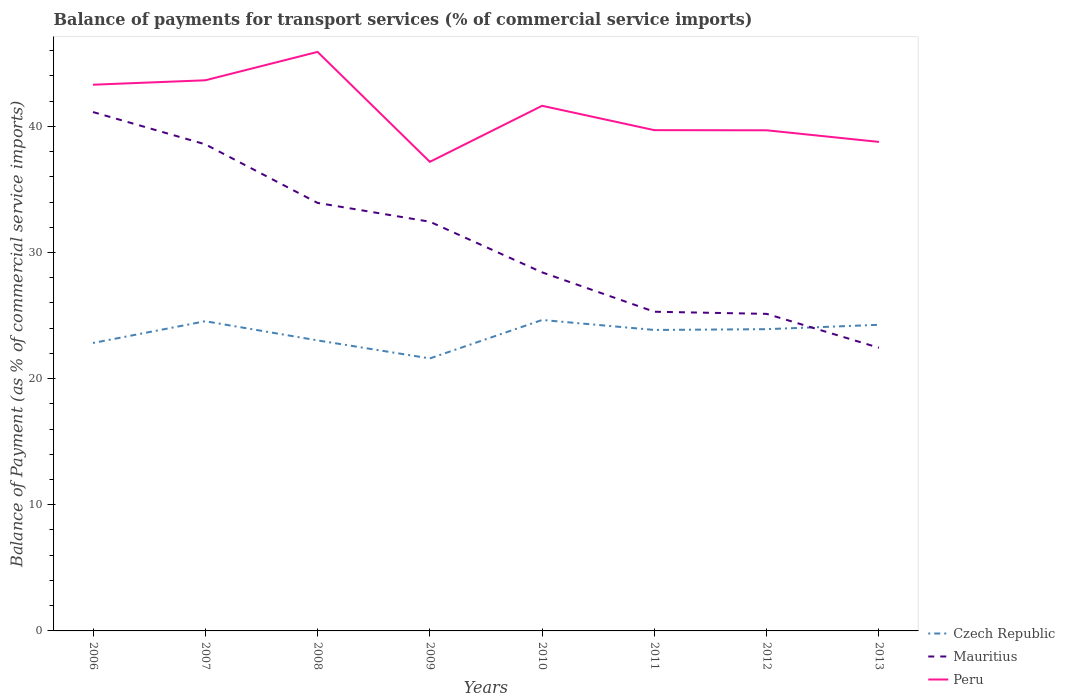Across all years, what is the maximum balance of payments for transport services in Czech Republic?
Give a very brief answer. 21.6. In which year was the balance of payments for transport services in Peru maximum?
Your answer should be very brief. 2009. What is the total balance of payments for transport services in Mauritius in the graph?
Provide a short and direct response. 2.86. What is the difference between the highest and the second highest balance of payments for transport services in Czech Republic?
Offer a very short reply. 3.05. What is the difference between the highest and the lowest balance of payments for transport services in Peru?
Provide a succinct answer. 4. How many lines are there?
Offer a terse response. 3. What is the difference between two consecutive major ticks on the Y-axis?
Provide a short and direct response. 10. Are the values on the major ticks of Y-axis written in scientific E-notation?
Provide a succinct answer. No. Does the graph contain any zero values?
Your response must be concise. No. Where does the legend appear in the graph?
Offer a very short reply. Bottom right. How many legend labels are there?
Your response must be concise. 3. How are the legend labels stacked?
Your answer should be very brief. Vertical. What is the title of the graph?
Ensure brevity in your answer.  Balance of payments for transport services (% of commercial service imports). Does "East Asia (developing only)" appear as one of the legend labels in the graph?
Give a very brief answer. No. What is the label or title of the X-axis?
Keep it short and to the point. Years. What is the label or title of the Y-axis?
Keep it short and to the point. Balance of Payment (as % of commercial service imports). What is the Balance of Payment (as % of commercial service imports) in Czech Republic in 2006?
Make the answer very short. 22.82. What is the Balance of Payment (as % of commercial service imports) of Mauritius in 2006?
Your answer should be very brief. 41.13. What is the Balance of Payment (as % of commercial service imports) of Peru in 2006?
Provide a succinct answer. 43.3. What is the Balance of Payment (as % of commercial service imports) of Czech Republic in 2007?
Provide a short and direct response. 24.55. What is the Balance of Payment (as % of commercial service imports) of Mauritius in 2007?
Your response must be concise. 38.57. What is the Balance of Payment (as % of commercial service imports) in Peru in 2007?
Provide a succinct answer. 43.65. What is the Balance of Payment (as % of commercial service imports) in Czech Republic in 2008?
Your response must be concise. 23.03. What is the Balance of Payment (as % of commercial service imports) in Mauritius in 2008?
Give a very brief answer. 33.93. What is the Balance of Payment (as % of commercial service imports) in Peru in 2008?
Make the answer very short. 45.9. What is the Balance of Payment (as % of commercial service imports) in Czech Republic in 2009?
Your answer should be compact. 21.6. What is the Balance of Payment (as % of commercial service imports) in Mauritius in 2009?
Provide a succinct answer. 32.44. What is the Balance of Payment (as % of commercial service imports) in Peru in 2009?
Offer a terse response. 37.18. What is the Balance of Payment (as % of commercial service imports) of Czech Republic in 2010?
Ensure brevity in your answer.  24.65. What is the Balance of Payment (as % of commercial service imports) in Mauritius in 2010?
Offer a very short reply. 28.42. What is the Balance of Payment (as % of commercial service imports) of Peru in 2010?
Your answer should be compact. 41.63. What is the Balance of Payment (as % of commercial service imports) in Czech Republic in 2011?
Your response must be concise. 23.86. What is the Balance of Payment (as % of commercial service imports) in Mauritius in 2011?
Offer a terse response. 25.3. What is the Balance of Payment (as % of commercial service imports) in Peru in 2011?
Provide a succinct answer. 39.69. What is the Balance of Payment (as % of commercial service imports) in Czech Republic in 2012?
Ensure brevity in your answer.  23.92. What is the Balance of Payment (as % of commercial service imports) of Mauritius in 2012?
Provide a short and direct response. 25.13. What is the Balance of Payment (as % of commercial service imports) of Peru in 2012?
Offer a terse response. 39.68. What is the Balance of Payment (as % of commercial service imports) of Czech Republic in 2013?
Make the answer very short. 24.27. What is the Balance of Payment (as % of commercial service imports) in Mauritius in 2013?
Your answer should be very brief. 22.45. What is the Balance of Payment (as % of commercial service imports) of Peru in 2013?
Your answer should be very brief. 38.76. Across all years, what is the maximum Balance of Payment (as % of commercial service imports) in Czech Republic?
Keep it short and to the point. 24.65. Across all years, what is the maximum Balance of Payment (as % of commercial service imports) in Mauritius?
Make the answer very short. 41.13. Across all years, what is the maximum Balance of Payment (as % of commercial service imports) in Peru?
Offer a very short reply. 45.9. Across all years, what is the minimum Balance of Payment (as % of commercial service imports) of Czech Republic?
Make the answer very short. 21.6. Across all years, what is the minimum Balance of Payment (as % of commercial service imports) of Mauritius?
Offer a very short reply. 22.45. Across all years, what is the minimum Balance of Payment (as % of commercial service imports) of Peru?
Make the answer very short. 37.18. What is the total Balance of Payment (as % of commercial service imports) in Czech Republic in the graph?
Provide a succinct answer. 188.7. What is the total Balance of Payment (as % of commercial service imports) in Mauritius in the graph?
Offer a terse response. 247.37. What is the total Balance of Payment (as % of commercial service imports) of Peru in the graph?
Your answer should be compact. 329.8. What is the difference between the Balance of Payment (as % of commercial service imports) in Czech Republic in 2006 and that in 2007?
Provide a succinct answer. -1.72. What is the difference between the Balance of Payment (as % of commercial service imports) of Mauritius in 2006 and that in 2007?
Make the answer very short. 2.56. What is the difference between the Balance of Payment (as % of commercial service imports) in Peru in 2006 and that in 2007?
Your answer should be compact. -0.35. What is the difference between the Balance of Payment (as % of commercial service imports) of Czech Republic in 2006 and that in 2008?
Offer a very short reply. -0.2. What is the difference between the Balance of Payment (as % of commercial service imports) in Mauritius in 2006 and that in 2008?
Keep it short and to the point. 7.2. What is the difference between the Balance of Payment (as % of commercial service imports) in Peru in 2006 and that in 2008?
Offer a terse response. -2.6. What is the difference between the Balance of Payment (as % of commercial service imports) of Czech Republic in 2006 and that in 2009?
Your answer should be compact. 1.22. What is the difference between the Balance of Payment (as % of commercial service imports) in Mauritius in 2006 and that in 2009?
Offer a terse response. 8.69. What is the difference between the Balance of Payment (as % of commercial service imports) of Peru in 2006 and that in 2009?
Offer a very short reply. 6.11. What is the difference between the Balance of Payment (as % of commercial service imports) in Czech Republic in 2006 and that in 2010?
Ensure brevity in your answer.  -1.82. What is the difference between the Balance of Payment (as % of commercial service imports) in Mauritius in 2006 and that in 2010?
Your answer should be very brief. 12.71. What is the difference between the Balance of Payment (as % of commercial service imports) of Peru in 2006 and that in 2010?
Your answer should be very brief. 1.67. What is the difference between the Balance of Payment (as % of commercial service imports) of Czech Republic in 2006 and that in 2011?
Offer a terse response. -1.03. What is the difference between the Balance of Payment (as % of commercial service imports) of Mauritius in 2006 and that in 2011?
Provide a succinct answer. 15.83. What is the difference between the Balance of Payment (as % of commercial service imports) in Peru in 2006 and that in 2011?
Provide a short and direct response. 3.6. What is the difference between the Balance of Payment (as % of commercial service imports) in Czech Republic in 2006 and that in 2012?
Your response must be concise. -1.09. What is the difference between the Balance of Payment (as % of commercial service imports) in Mauritius in 2006 and that in 2012?
Give a very brief answer. 16. What is the difference between the Balance of Payment (as % of commercial service imports) of Peru in 2006 and that in 2012?
Your answer should be very brief. 3.61. What is the difference between the Balance of Payment (as % of commercial service imports) of Czech Republic in 2006 and that in 2013?
Your response must be concise. -1.44. What is the difference between the Balance of Payment (as % of commercial service imports) of Mauritius in 2006 and that in 2013?
Your answer should be very brief. 18.68. What is the difference between the Balance of Payment (as % of commercial service imports) of Peru in 2006 and that in 2013?
Offer a terse response. 4.53. What is the difference between the Balance of Payment (as % of commercial service imports) in Czech Republic in 2007 and that in 2008?
Ensure brevity in your answer.  1.52. What is the difference between the Balance of Payment (as % of commercial service imports) of Mauritius in 2007 and that in 2008?
Your response must be concise. 4.64. What is the difference between the Balance of Payment (as % of commercial service imports) of Peru in 2007 and that in 2008?
Provide a succinct answer. -2.25. What is the difference between the Balance of Payment (as % of commercial service imports) in Czech Republic in 2007 and that in 2009?
Your answer should be very brief. 2.95. What is the difference between the Balance of Payment (as % of commercial service imports) of Mauritius in 2007 and that in 2009?
Your answer should be very brief. 6.14. What is the difference between the Balance of Payment (as % of commercial service imports) of Peru in 2007 and that in 2009?
Your response must be concise. 6.46. What is the difference between the Balance of Payment (as % of commercial service imports) in Czech Republic in 2007 and that in 2010?
Provide a succinct answer. -0.1. What is the difference between the Balance of Payment (as % of commercial service imports) in Mauritius in 2007 and that in 2010?
Provide a succinct answer. 10.15. What is the difference between the Balance of Payment (as % of commercial service imports) in Peru in 2007 and that in 2010?
Make the answer very short. 2.02. What is the difference between the Balance of Payment (as % of commercial service imports) in Czech Republic in 2007 and that in 2011?
Offer a terse response. 0.69. What is the difference between the Balance of Payment (as % of commercial service imports) of Mauritius in 2007 and that in 2011?
Make the answer very short. 13.27. What is the difference between the Balance of Payment (as % of commercial service imports) in Peru in 2007 and that in 2011?
Ensure brevity in your answer.  3.95. What is the difference between the Balance of Payment (as % of commercial service imports) of Czech Republic in 2007 and that in 2012?
Offer a terse response. 0.63. What is the difference between the Balance of Payment (as % of commercial service imports) in Mauritius in 2007 and that in 2012?
Make the answer very short. 13.44. What is the difference between the Balance of Payment (as % of commercial service imports) in Peru in 2007 and that in 2012?
Give a very brief answer. 3.96. What is the difference between the Balance of Payment (as % of commercial service imports) of Czech Republic in 2007 and that in 2013?
Offer a very short reply. 0.28. What is the difference between the Balance of Payment (as % of commercial service imports) in Mauritius in 2007 and that in 2013?
Give a very brief answer. 16.13. What is the difference between the Balance of Payment (as % of commercial service imports) of Peru in 2007 and that in 2013?
Ensure brevity in your answer.  4.88. What is the difference between the Balance of Payment (as % of commercial service imports) of Czech Republic in 2008 and that in 2009?
Provide a short and direct response. 1.43. What is the difference between the Balance of Payment (as % of commercial service imports) in Mauritius in 2008 and that in 2009?
Offer a terse response. 1.49. What is the difference between the Balance of Payment (as % of commercial service imports) of Peru in 2008 and that in 2009?
Make the answer very short. 8.71. What is the difference between the Balance of Payment (as % of commercial service imports) of Czech Republic in 2008 and that in 2010?
Offer a very short reply. -1.62. What is the difference between the Balance of Payment (as % of commercial service imports) of Mauritius in 2008 and that in 2010?
Offer a very short reply. 5.51. What is the difference between the Balance of Payment (as % of commercial service imports) in Peru in 2008 and that in 2010?
Provide a succinct answer. 4.27. What is the difference between the Balance of Payment (as % of commercial service imports) of Czech Republic in 2008 and that in 2011?
Provide a succinct answer. -0.83. What is the difference between the Balance of Payment (as % of commercial service imports) in Mauritius in 2008 and that in 2011?
Make the answer very short. 8.63. What is the difference between the Balance of Payment (as % of commercial service imports) in Peru in 2008 and that in 2011?
Provide a succinct answer. 6.2. What is the difference between the Balance of Payment (as % of commercial service imports) in Czech Republic in 2008 and that in 2012?
Make the answer very short. -0.89. What is the difference between the Balance of Payment (as % of commercial service imports) of Mauritius in 2008 and that in 2012?
Provide a succinct answer. 8.8. What is the difference between the Balance of Payment (as % of commercial service imports) in Peru in 2008 and that in 2012?
Make the answer very short. 6.21. What is the difference between the Balance of Payment (as % of commercial service imports) of Czech Republic in 2008 and that in 2013?
Your answer should be compact. -1.24. What is the difference between the Balance of Payment (as % of commercial service imports) of Mauritius in 2008 and that in 2013?
Keep it short and to the point. 11.48. What is the difference between the Balance of Payment (as % of commercial service imports) of Peru in 2008 and that in 2013?
Your response must be concise. 7.14. What is the difference between the Balance of Payment (as % of commercial service imports) in Czech Republic in 2009 and that in 2010?
Ensure brevity in your answer.  -3.05. What is the difference between the Balance of Payment (as % of commercial service imports) in Mauritius in 2009 and that in 2010?
Keep it short and to the point. 4.01. What is the difference between the Balance of Payment (as % of commercial service imports) in Peru in 2009 and that in 2010?
Ensure brevity in your answer.  -4.44. What is the difference between the Balance of Payment (as % of commercial service imports) in Czech Republic in 2009 and that in 2011?
Provide a succinct answer. -2.26. What is the difference between the Balance of Payment (as % of commercial service imports) in Mauritius in 2009 and that in 2011?
Give a very brief answer. 7.14. What is the difference between the Balance of Payment (as % of commercial service imports) of Peru in 2009 and that in 2011?
Your answer should be compact. -2.51. What is the difference between the Balance of Payment (as % of commercial service imports) in Czech Republic in 2009 and that in 2012?
Your answer should be compact. -2.32. What is the difference between the Balance of Payment (as % of commercial service imports) in Mauritius in 2009 and that in 2012?
Provide a short and direct response. 7.3. What is the difference between the Balance of Payment (as % of commercial service imports) in Peru in 2009 and that in 2012?
Keep it short and to the point. -2.5. What is the difference between the Balance of Payment (as % of commercial service imports) in Czech Republic in 2009 and that in 2013?
Provide a short and direct response. -2.66. What is the difference between the Balance of Payment (as % of commercial service imports) of Mauritius in 2009 and that in 2013?
Offer a terse response. 9.99. What is the difference between the Balance of Payment (as % of commercial service imports) of Peru in 2009 and that in 2013?
Provide a short and direct response. -1.58. What is the difference between the Balance of Payment (as % of commercial service imports) of Czech Republic in 2010 and that in 2011?
Make the answer very short. 0.79. What is the difference between the Balance of Payment (as % of commercial service imports) in Mauritius in 2010 and that in 2011?
Provide a succinct answer. 3.12. What is the difference between the Balance of Payment (as % of commercial service imports) in Peru in 2010 and that in 2011?
Ensure brevity in your answer.  1.93. What is the difference between the Balance of Payment (as % of commercial service imports) in Czech Republic in 2010 and that in 2012?
Your answer should be very brief. 0.73. What is the difference between the Balance of Payment (as % of commercial service imports) of Mauritius in 2010 and that in 2012?
Make the answer very short. 3.29. What is the difference between the Balance of Payment (as % of commercial service imports) in Peru in 2010 and that in 2012?
Provide a succinct answer. 1.94. What is the difference between the Balance of Payment (as % of commercial service imports) of Czech Republic in 2010 and that in 2013?
Offer a very short reply. 0.38. What is the difference between the Balance of Payment (as % of commercial service imports) in Mauritius in 2010 and that in 2013?
Provide a succinct answer. 5.98. What is the difference between the Balance of Payment (as % of commercial service imports) in Peru in 2010 and that in 2013?
Give a very brief answer. 2.86. What is the difference between the Balance of Payment (as % of commercial service imports) in Czech Republic in 2011 and that in 2012?
Offer a very short reply. -0.06. What is the difference between the Balance of Payment (as % of commercial service imports) of Mauritius in 2011 and that in 2012?
Offer a very short reply. 0.17. What is the difference between the Balance of Payment (as % of commercial service imports) of Peru in 2011 and that in 2012?
Your answer should be compact. 0.01. What is the difference between the Balance of Payment (as % of commercial service imports) of Czech Republic in 2011 and that in 2013?
Your answer should be very brief. -0.41. What is the difference between the Balance of Payment (as % of commercial service imports) of Mauritius in 2011 and that in 2013?
Keep it short and to the point. 2.86. What is the difference between the Balance of Payment (as % of commercial service imports) of Peru in 2011 and that in 2013?
Your response must be concise. 0.93. What is the difference between the Balance of Payment (as % of commercial service imports) of Czech Republic in 2012 and that in 2013?
Offer a terse response. -0.35. What is the difference between the Balance of Payment (as % of commercial service imports) in Mauritius in 2012 and that in 2013?
Give a very brief answer. 2.69. What is the difference between the Balance of Payment (as % of commercial service imports) of Peru in 2012 and that in 2013?
Keep it short and to the point. 0.92. What is the difference between the Balance of Payment (as % of commercial service imports) in Czech Republic in 2006 and the Balance of Payment (as % of commercial service imports) in Mauritius in 2007?
Keep it short and to the point. -15.75. What is the difference between the Balance of Payment (as % of commercial service imports) in Czech Republic in 2006 and the Balance of Payment (as % of commercial service imports) in Peru in 2007?
Ensure brevity in your answer.  -20.82. What is the difference between the Balance of Payment (as % of commercial service imports) of Mauritius in 2006 and the Balance of Payment (as % of commercial service imports) of Peru in 2007?
Provide a succinct answer. -2.52. What is the difference between the Balance of Payment (as % of commercial service imports) of Czech Republic in 2006 and the Balance of Payment (as % of commercial service imports) of Mauritius in 2008?
Provide a succinct answer. -11.1. What is the difference between the Balance of Payment (as % of commercial service imports) in Czech Republic in 2006 and the Balance of Payment (as % of commercial service imports) in Peru in 2008?
Offer a very short reply. -23.07. What is the difference between the Balance of Payment (as % of commercial service imports) of Mauritius in 2006 and the Balance of Payment (as % of commercial service imports) of Peru in 2008?
Make the answer very short. -4.77. What is the difference between the Balance of Payment (as % of commercial service imports) in Czech Republic in 2006 and the Balance of Payment (as % of commercial service imports) in Mauritius in 2009?
Provide a succinct answer. -9.61. What is the difference between the Balance of Payment (as % of commercial service imports) of Czech Republic in 2006 and the Balance of Payment (as % of commercial service imports) of Peru in 2009?
Offer a very short reply. -14.36. What is the difference between the Balance of Payment (as % of commercial service imports) in Mauritius in 2006 and the Balance of Payment (as % of commercial service imports) in Peru in 2009?
Ensure brevity in your answer.  3.95. What is the difference between the Balance of Payment (as % of commercial service imports) in Czech Republic in 2006 and the Balance of Payment (as % of commercial service imports) in Mauritius in 2010?
Your answer should be very brief. -5.6. What is the difference between the Balance of Payment (as % of commercial service imports) of Czech Republic in 2006 and the Balance of Payment (as % of commercial service imports) of Peru in 2010?
Your answer should be very brief. -18.8. What is the difference between the Balance of Payment (as % of commercial service imports) of Mauritius in 2006 and the Balance of Payment (as % of commercial service imports) of Peru in 2010?
Your answer should be compact. -0.5. What is the difference between the Balance of Payment (as % of commercial service imports) in Czech Republic in 2006 and the Balance of Payment (as % of commercial service imports) in Mauritius in 2011?
Your response must be concise. -2.48. What is the difference between the Balance of Payment (as % of commercial service imports) of Czech Republic in 2006 and the Balance of Payment (as % of commercial service imports) of Peru in 2011?
Offer a terse response. -16.87. What is the difference between the Balance of Payment (as % of commercial service imports) in Mauritius in 2006 and the Balance of Payment (as % of commercial service imports) in Peru in 2011?
Offer a terse response. 1.44. What is the difference between the Balance of Payment (as % of commercial service imports) of Czech Republic in 2006 and the Balance of Payment (as % of commercial service imports) of Mauritius in 2012?
Your answer should be very brief. -2.31. What is the difference between the Balance of Payment (as % of commercial service imports) in Czech Republic in 2006 and the Balance of Payment (as % of commercial service imports) in Peru in 2012?
Provide a succinct answer. -16.86. What is the difference between the Balance of Payment (as % of commercial service imports) in Mauritius in 2006 and the Balance of Payment (as % of commercial service imports) in Peru in 2012?
Provide a short and direct response. 1.45. What is the difference between the Balance of Payment (as % of commercial service imports) of Czech Republic in 2006 and the Balance of Payment (as % of commercial service imports) of Mauritius in 2013?
Offer a very short reply. 0.38. What is the difference between the Balance of Payment (as % of commercial service imports) in Czech Republic in 2006 and the Balance of Payment (as % of commercial service imports) in Peru in 2013?
Keep it short and to the point. -15.94. What is the difference between the Balance of Payment (as % of commercial service imports) in Mauritius in 2006 and the Balance of Payment (as % of commercial service imports) in Peru in 2013?
Your answer should be very brief. 2.37. What is the difference between the Balance of Payment (as % of commercial service imports) of Czech Republic in 2007 and the Balance of Payment (as % of commercial service imports) of Mauritius in 2008?
Make the answer very short. -9.38. What is the difference between the Balance of Payment (as % of commercial service imports) in Czech Republic in 2007 and the Balance of Payment (as % of commercial service imports) in Peru in 2008?
Your answer should be compact. -21.35. What is the difference between the Balance of Payment (as % of commercial service imports) of Mauritius in 2007 and the Balance of Payment (as % of commercial service imports) of Peru in 2008?
Provide a short and direct response. -7.33. What is the difference between the Balance of Payment (as % of commercial service imports) in Czech Republic in 2007 and the Balance of Payment (as % of commercial service imports) in Mauritius in 2009?
Provide a succinct answer. -7.89. What is the difference between the Balance of Payment (as % of commercial service imports) in Czech Republic in 2007 and the Balance of Payment (as % of commercial service imports) in Peru in 2009?
Offer a terse response. -12.63. What is the difference between the Balance of Payment (as % of commercial service imports) in Mauritius in 2007 and the Balance of Payment (as % of commercial service imports) in Peru in 2009?
Your answer should be very brief. 1.39. What is the difference between the Balance of Payment (as % of commercial service imports) of Czech Republic in 2007 and the Balance of Payment (as % of commercial service imports) of Mauritius in 2010?
Make the answer very short. -3.87. What is the difference between the Balance of Payment (as % of commercial service imports) in Czech Republic in 2007 and the Balance of Payment (as % of commercial service imports) in Peru in 2010?
Ensure brevity in your answer.  -17.08. What is the difference between the Balance of Payment (as % of commercial service imports) in Mauritius in 2007 and the Balance of Payment (as % of commercial service imports) in Peru in 2010?
Offer a terse response. -3.05. What is the difference between the Balance of Payment (as % of commercial service imports) of Czech Republic in 2007 and the Balance of Payment (as % of commercial service imports) of Mauritius in 2011?
Provide a succinct answer. -0.75. What is the difference between the Balance of Payment (as % of commercial service imports) in Czech Republic in 2007 and the Balance of Payment (as % of commercial service imports) in Peru in 2011?
Offer a terse response. -15.15. What is the difference between the Balance of Payment (as % of commercial service imports) in Mauritius in 2007 and the Balance of Payment (as % of commercial service imports) in Peru in 2011?
Offer a terse response. -1.12. What is the difference between the Balance of Payment (as % of commercial service imports) in Czech Republic in 2007 and the Balance of Payment (as % of commercial service imports) in Mauritius in 2012?
Offer a very short reply. -0.58. What is the difference between the Balance of Payment (as % of commercial service imports) of Czech Republic in 2007 and the Balance of Payment (as % of commercial service imports) of Peru in 2012?
Offer a very short reply. -15.14. What is the difference between the Balance of Payment (as % of commercial service imports) of Mauritius in 2007 and the Balance of Payment (as % of commercial service imports) of Peru in 2012?
Your answer should be very brief. -1.11. What is the difference between the Balance of Payment (as % of commercial service imports) in Czech Republic in 2007 and the Balance of Payment (as % of commercial service imports) in Mauritius in 2013?
Your answer should be compact. 2.1. What is the difference between the Balance of Payment (as % of commercial service imports) in Czech Republic in 2007 and the Balance of Payment (as % of commercial service imports) in Peru in 2013?
Your response must be concise. -14.21. What is the difference between the Balance of Payment (as % of commercial service imports) of Mauritius in 2007 and the Balance of Payment (as % of commercial service imports) of Peru in 2013?
Give a very brief answer. -0.19. What is the difference between the Balance of Payment (as % of commercial service imports) in Czech Republic in 2008 and the Balance of Payment (as % of commercial service imports) in Mauritius in 2009?
Your answer should be very brief. -9.41. What is the difference between the Balance of Payment (as % of commercial service imports) of Czech Republic in 2008 and the Balance of Payment (as % of commercial service imports) of Peru in 2009?
Provide a succinct answer. -14.15. What is the difference between the Balance of Payment (as % of commercial service imports) in Mauritius in 2008 and the Balance of Payment (as % of commercial service imports) in Peru in 2009?
Your answer should be very brief. -3.26. What is the difference between the Balance of Payment (as % of commercial service imports) of Czech Republic in 2008 and the Balance of Payment (as % of commercial service imports) of Mauritius in 2010?
Ensure brevity in your answer.  -5.39. What is the difference between the Balance of Payment (as % of commercial service imports) of Czech Republic in 2008 and the Balance of Payment (as % of commercial service imports) of Peru in 2010?
Ensure brevity in your answer.  -18.6. What is the difference between the Balance of Payment (as % of commercial service imports) in Mauritius in 2008 and the Balance of Payment (as % of commercial service imports) in Peru in 2010?
Your answer should be compact. -7.7. What is the difference between the Balance of Payment (as % of commercial service imports) in Czech Republic in 2008 and the Balance of Payment (as % of commercial service imports) in Mauritius in 2011?
Your response must be concise. -2.27. What is the difference between the Balance of Payment (as % of commercial service imports) of Czech Republic in 2008 and the Balance of Payment (as % of commercial service imports) of Peru in 2011?
Provide a succinct answer. -16.67. What is the difference between the Balance of Payment (as % of commercial service imports) in Mauritius in 2008 and the Balance of Payment (as % of commercial service imports) in Peru in 2011?
Provide a short and direct response. -5.77. What is the difference between the Balance of Payment (as % of commercial service imports) in Czech Republic in 2008 and the Balance of Payment (as % of commercial service imports) in Mauritius in 2012?
Provide a succinct answer. -2.1. What is the difference between the Balance of Payment (as % of commercial service imports) of Czech Republic in 2008 and the Balance of Payment (as % of commercial service imports) of Peru in 2012?
Ensure brevity in your answer.  -16.66. What is the difference between the Balance of Payment (as % of commercial service imports) in Mauritius in 2008 and the Balance of Payment (as % of commercial service imports) in Peru in 2012?
Offer a terse response. -5.76. What is the difference between the Balance of Payment (as % of commercial service imports) of Czech Republic in 2008 and the Balance of Payment (as % of commercial service imports) of Mauritius in 2013?
Give a very brief answer. 0.58. What is the difference between the Balance of Payment (as % of commercial service imports) of Czech Republic in 2008 and the Balance of Payment (as % of commercial service imports) of Peru in 2013?
Give a very brief answer. -15.73. What is the difference between the Balance of Payment (as % of commercial service imports) of Mauritius in 2008 and the Balance of Payment (as % of commercial service imports) of Peru in 2013?
Your response must be concise. -4.83. What is the difference between the Balance of Payment (as % of commercial service imports) of Czech Republic in 2009 and the Balance of Payment (as % of commercial service imports) of Mauritius in 2010?
Provide a succinct answer. -6.82. What is the difference between the Balance of Payment (as % of commercial service imports) in Czech Republic in 2009 and the Balance of Payment (as % of commercial service imports) in Peru in 2010?
Offer a terse response. -20.03. What is the difference between the Balance of Payment (as % of commercial service imports) in Mauritius in 2009 and the Balance of Payment (as % of commercial service imports) in Peru in 2010?
Offer a very short reply. -9.19. What is the difference between the Balance of Payment (as % of commercial service imports) in Czech Republic in 2009 and the Balance of Payment (as % of commercial service imports) in Mauritius in 2011?
Offer a terse response. -3.7. What is the difference between the Balance of Payment (as % of commercial service imports) in Czech Republic in 2009 and the Balance of Payment (as % of commercial service imports) in Peru in 2011?
Give a very brief answer. -18.09. What is the difference between the Balance of Payment (as % of commercial service imports) in Mauritius in 2009 and the Balance of Payment (as % of commercial service imports) in Peru in 2011?
Provide a succinct answer. -7.26. What is the difference between the Balance of Payment (as % of commercial service imports) in Czech Republic in 2009 and the Balance of Payment (as % of commercial service imports) in Mauritius in 2012?
Your answer should be very brief. -3.53. What is the difference between the Balance of Payment (as % of commercial service imports) of Czech Republic in 2009 and the Balance of Payment (as % of commercial service imports) of Peru in 2012?
Keep it short and to the point. -18.08. What is the difference between the Balance of Payment (as % of commercial service imports) in Mauritius in 2009 and the Balance of Payment (as % of commercial service imports) in Peru in 2012?
Offer a very short reply. -7.25. What is the difference between the Balance of Payment (as % of commercial service imports) of Czech Republic in 2009 and the Balance of Payment (as % of commercial service imports) of Mauritius in 2013?
Provide a short and direct response. -0.84. What is the difference between the Balance of Payment (as % of commercial service imports) in Czech Republic in 2009 and the Balance of Payment (as % of commercial service imports) in Peru in 2013?
Offer a very short reply. -17.16. What is the difference between the Balance of Payment (as % of commercial service imports) in Mauritius in 2009 and the Balance of Payment (as % of commercial service imports) in Peru in 2013?
Keep it short and to the point. -6.33. What is the difference between the Balance of Payment (as % of commercial service imports) in Czech Republic in 2010 and the Balance of Payment (as % of commercial service imports) in Mauritius in 2011?
Ensure brevity in your answer.  -0.65. What is the difference between the Balance of Payment (as % of commercial service imports) of Czech Republic in 2010 and the Balance of Payment (as % of commercial service imports) of Peru in 2011?
Offer a very short reply. -15.05. What is the difference between the Balance of Payment (as % of commercial service imports) of Mauritius in 2010 and the Balance of Payment (as % of commercial service imports) of Peru in 2011?
Make the answer very short. -11.27. What is the difference between the Balance of Payment (as % of commercial service imports) in Czech Republic in 2010 and the Balance of Payment (as % of commercial service imports) in Mauritius in 2012?
Your answer should be compact. -0.48. What is the difference between the Balance of Payment (as % of commercial service imports) in Czech Republic in 2010 and the Balance of Payment (as % of commercial service imports) in Peru in 2012?
Provide a short and direct response. -15.04. What is the difference between the Balance of Payment (as % of commercial service imports) of Mauritius in 2010 and the Balance of Payment (as % of commercial service imports) of Peru in 2012?
Your response must be concise. -11.26. What is the difference between the Balance of Payment (as % of commercial service imports) in Czech Republic in 2010 and the Balance of Payment (as % of commercial service imports) in Mauritius in 2013?
Ensure brevity in your answer.  2.2. What is the difference between the Balance of Payment (as % of commercial service imports) of Czech Republic in 2010 and the Balance of Payment (as % of commercial service imports) of Peru in 2013?
Your answer should be compact. -14.11. What is the difference between the Balance of Payment (as % of commercial service imports) in Mauritius in 2010 and the Balance of Payment (as % of commercial service imports) in Peru in 2013?
Make the answer very short. -10.34. What is the difference between the Balance of Payment (as % of commercial service imports) of Czech Republic in 2011 and the Balance of Payment (as % of commercial service imports) of Mauritius in 2012?
Your answer should be compact. -1.27. What is the difference between the Balance of Payment (as % of commercial service imports) of Czech Republic in 2011 and the Balance of Payment (as % of commercial service imports) of Peru in 2012?
Ensure brevity in your answer.  -15.83. What is the difference between the Balance of Payment (as % of commercial service imports) in Mauritius in 2011 and the Balance of Payment (as % of commercial service imports) in Peru in 2012?
Provide a succinct answer. -14.38. What is the difference between the Balance of Payment (as % of commercial service imports) of Czech Republic in 2011 and the Balance of Payment (as % of commercial service imports) of Mauritius in 2013?
Provide a succinct answer. 1.41. What is the difference between the Balance of Payment (as % of commercial service imports) in Czech Republic in 2011 and the Balance of Payment (as % of commercial service imports) in Peru in 2013?
Ensure brevity in your answer.  -14.91. What is the difference between the Balance of Payment (as % of commercial service imports) of Mauritius in 2011 and the Balance of Payment (as % of commercial service imports) of Peru in 2013?
Your answer should be very brief. -13.46. What is the difference between the Balance of Payment (as % of commercial service imports) of Czech Republic in 2012 and the Balance of Payment (as % of commercial service imports) of Mauritius in 2013?
Keep it short and to the point. 1.47. What is the difference between the Balance of Payment (as % of commercial service imports) in Czech Republic in 2012 and the Balance of Payment (as % of commercial service imports) in Peru in 2013?
Keep it short and to the point. -14.84. What is the difference between the Balance of Payment (as % of commercial service imports) of Mauritius in 2012 and the Balance of Payment (as % of commercial service imports) of Peru in 2013?
Your response must be concise. -13.63. What is the average Balance of Payment (as % of commercial service imports) of Czech Republic per year?
Your answer should be compact. 23.59. What is the average Balance of Payment (as % of commercial service imports) of Mauritius per year?
Give a very brief answer. 30.92. What is the average Balance of Payment (as % of commercial service imports) of Peru per year?
Offer a terse response. 41.22. In the year 2006, what is the difference between the Balance of Payment (as % of commercial service imports) of Czech Republic and Balance of Payment (as % of commercial service imports) of Mauritius?
Your response must be concise. -18.31. In the year 2006, what is the difference between the Balance of Payment (as % of commercial service imports) in Czech Republic and Balance of Payment (as % of commercial service imports) in Peru?
Give a very brief answer. -20.47. In the year 2006, what is the difference between the Balance of Payment (as % of commercial service imports) of Mauritius and Balance of Payment (as % of commercial service imports) of Peru?
Your answer should be compact. -2.17. In the year 2007, what is the difference between the Balance of Payment (as % of commercial service imports) in Czech Republic and Balance of Payment (as % of commercial service imports) in Mauritius?
Make the answer very short. -14.02. In the year 2007, what is the difference between the Balance of Payment (as % of commercial service imports) of Czech Republic and Balance of Payment (as % of commercial service imports) of Peru?
Make the answer very short. -19.1. In the year 2007, what is the difference between the Balance of Payment (as % of commercial service imports) in Mauritius and Balance of Payment (as % of commercial service imports) in Peru?
Offer a terse response. -5.08. In the year 2008, what is the difference between the Balance of Payment (as % of commercial service imports) of Czech Republic and Balance of Payment (as % of commercial service imports) of Mauritius?
Ensure brevity in your answer.  -10.9. In the year 2008, what is the difference between the Balance of Payment (as % of commercial service imports) of Czech Republic and Balance of Payment (as % of commercial service imports) of Peru?
Make the answer very short. -22.87. In the year 2008, what is the difference between the Balance of Payment (as % of commercial service imports) of Mauritius and Balance of Payment (as % of commercial service imports) of Peru?
Give a very brief answer. -11.97. In the year 2009, what is the difference between the Balance of Payment (as % of commercial service imports) in Czech Republic and Balance of Payment (as % of commercial service imports) in Mauritius?
Provide a succinct answer. -10.84. In the year 2009, what is the difference between the Balance of Payment (as % of commercial service imports) of Czech Republic and Balance of Payment (as % of commercial service imports) of Peru?
Offer a very short reply. -15.58. In the year 2009, what is the difference between the Balance of Payment (as % of commercial service imports) in Mauritius and Balance of Payment (as % of commercial service imports) in Peru?
Provide a short and direct response. -4.75. In the year 2010, what is the difference between the Balance of Payment (as % of commercial service imports) of Czech Republic and Balance of Payment (as % of commercial service imports) of Mauritius?
Your answer should be very brief. -3.77. In the year 2010, what is the difference between the Balance of Payment (as % of commercial service imports) in Czech Republic and Balance of Payment (as % of commercial service imports) in Peru?
Give a very brief answer. -16.98. In the year 2010, what is the difference between the Balance of Payment (as % of commercial service imports) in Mauritius and Balance of Payment (as % of commercial service imports) in Peru?
Offer a terse response. -13.2. In the year 2011, what is the difference between the Balance of Payment (as % of commercial service imports) of Czech Republic and Balance of Payment (as % of commercial service imports) of Mauritius?
Give a very brief answer. -1.44. In the year 2011, what is the difference between the Balance of Payment (as % of commercial service imports) in Czech Republic and Balance of Payment (as % of commercial service imports) in Peru?
Offer a very short reply. -15.84. In the year 2011, what is the difference between the Balance of Payment (as % of commercial service imports) in Mauritius and Balance of Payment (as % of commercial service imports) in Peru?
Your answer should be compact. -14.39. In the year 2012, what is the difference between the Balance of Payment (as % of commercial service imports) of Czech Republic and Balance of Payment (as % of commercial service imports) of Mauritius?
Your answer should be compact. -1.21. In the year 2012, what is the difference between the Balance of Payment (as % of commercial service imports) in Czech Republic and Balance of Payment (as % of commercial service imports) in Peru?
Give a very brief answer. -15.77. In the year 2012, what is the difference between the Balance of Payment (as % of commercial service imports) of Mauritius and Balance of Payment (as % of commercial service imports) of Peru?
Give a very brief answer. -14.55. In the year 2013, what is the difference between the Balance of Payment (as % of commercial service imports) of Czech Republic and Balance of Payment (as % of commercial service imports) of Mauritius?
Your answer should be very brief. 1.82. In the year 2013, what is the difference between the Balance of Payment (as % of commercial service imports) in Czech Republic and Balance of Payment (as % of commercial service imports) in Peru?
Provide a short and direct response. -14.5. In the year 2013, what is the difference between the Balance of Payment (as % of commercial service imports) in Mauritius and Balance of Payment (as % of commercial service imports) in Peru?
Give a very brief answer. -16.32. What is the ratio of the Balance of Payment (as % of commercial service imports) in Czech Republic in 2006 to that in 2007?
Ensure brevity in your answer.  0.93. What is the ratio of the Balance of Payment (as % of commercial service imports) of Mauritius in 2006 to that in 2007?
Offer a terse response. 1.07. What is the ratio of the Balance of Payment (as % of commercial service imports) in Peru in 2006 to that in 2007?
Your response must be concise. 0.99. What is the ratio of the Balance of Payment (as % of commercial service imports) of Czech Republic in 2006 to that in 2008?
Give a very brief answer. 0.99. What is the ratio of the Balance of Payment (as % of commercial service imports) in Mauritius in 2006 to that in 2008?
Your answer should be very brief. 1.21. What is the ratio of the Balance of Payment (as % of commercial service imports) in Peru in 2006 to that in 2008?
Give a very brief answer. 0.94. What is the ratio of the Balance of Payment (as % of commercial service imports) in Czech Republic in 2006 to that in 2009?
Provide a short and direct response. 1.06. What is the ratio of the Balance of Payment (as % of commercial service imports) in Mauritius in 2006 to that in 2009?
Your answer should be compact. 1.27. What is the ratio of the Balance of Payment (as % of commercial service imports) of Peru in 2006 to that in 2009?
Give a very brief answer. 1.16. What is the ratio of the Balance of Payment (as % of commercial service imports) in Czech Republic in 2006 to that in 2010?
Your response must be concise. 0.93. What is the ratio of the Balance of Payment (as % of commercial service imports) in Mauritius in 2006 to that in 2010?
Your answer should be very brief. 1.45. What is the ratio of the Balance of Payment (as % of commercial service imports) of Peru in 2006 to that in 2010?
Make the answer very short. 1.04. What is the ratio of the Balance of Payment (as % of commercial service imports) of Czech Republic in 2006 to that in 2011?
Make the answer very short. 0.96. What is the ratio of the Balance of Payment (as % of commercial service imports) of Mauritius in 2006 to that in 2011?
Give a very brief answer. 1.63. What is the ratio of the Balance of Payment (as % of commercial service imports) of Peru in 2006 to that in 2011?
Provide a succinct answer. 1.09. What is the ratio of the Balance of Payment (as % of commercial service imports) of Czech Republic in 2006 to that in 2012?
Give a very brief answer. 0.95. What is the ratio of the Balance of Payment (as % of commercial service imports) of Mauritius in 2006 to that in 2012?
Provide a succinct answer. 1.64. What is the ratio of the Balance of Payment (as % of commercial service imports) of Peru in 2006 to that in 2012?
Offer a very short reply. 1.09. What is the ratio of the Balance of Payment (as % of commercial service imports) of Czech Republic in 2006 to that in 2013?
Make the answer very short. 0.94. What is the ratio of the Balance of Payment (as % of commercial service imports) of Mauritius in 2006 to that in 2013?
Ensure brevity in your answer.  1.83. What is the ratio of the Balance of Payment (as % of commercial service imports) of Peru in 2006 to that in 2013?
Your response must be concise. 1.12. What is the ratio of the Balance of Payment (as % of commercial service imports) of Czech Republic in 2007 to that in 2008?
Provide a short and direct response. 1.07. What is the ratio of the Balance of Payment (as % of commercial service imports) of Mauritius in 2007 to that in 2008?
Ensure brevity in your answer.  1.14. What is the ratio of the Balance of Payment (as % of commercial service imports) in Peru in 2007 to that in 2008?
Your answer should be compact. 0.95. What is the ratio of the Balance of Payment (as % of commercial service imports) in Czech Republic in 2007 to that in 2009?
Provide a succinct answer. 1.14. What is the ratio of the Balance of Payment (as % of commercial service imports) in Mauritius in 2007 to that in 2009?
Give a very brief answer. 1.19. What is the ratio of the Balance of Payment (as % of commercial service imports) in Peru in 2007 to that in 2009?
Offer a terse response. 1.17. What is the ratio of the Balance of Payment (as % of commercial service imports) of Mauritius in 2007 to that in 2010?
Offer a terse response. 1.36. What is the ratio of the Balance of Payment (as % of commercial service imports) in Peru in 2007 to that in 2010?
Ensure brevity in your answer.  1.05. What is the ratio of the Balance of Payment (as % of commercial service imports) in Czech Republic in 2007 to that in 2011?
Give a very brief answer. 1.03. What is the ratio of the Balance of Payment (as % of commercial service imports) of Mauritius in 2007 to that in 2011?
Provide a succinct answer. 1.52. What is the ratio of the Balance of Payment (as % of commercial service imports) of Peru in 2007 to that in 2011?
Your answer should be compact. 1.1. What is the ratio of the Balance of Payment (as % of commercial service imports) in Czech Republic in 2007 to that in 2012?
Your answer should be compact. 1.03. What is the ratio of the Balance of Payment (as % of commercial service imports) in Mauritius in 2007 to that in 2012?
Provide a short and direct response. 1.53. What is the ratio of the Balance of Payment (as % of commercial service imports) in Peru in 2007 to that in 2012?
Give a very brief answer. 1.1. What is the ratio of the Balance of Payment (as % of commercial service imports) in Czech Republic in 2007 to that in 2013?
Provide a short and direct response. 1.01. What is the ratio of the Balance of Payment (as % of commercial service imports) of Mauritius in 2007 to that in 2013?
Ensure brevity in your answer.  1.72. What is the ratio of the Balance of Payment (as % of commercial service imports) in Peru in 2007 to that in 2013?
Keep it short and to the point. 1.13. What is the ratio of the Balance of Payment (as % of commercial service imports) of Czech Republic in 2008 to that in 2009?
Make the answer very short. 1.07. What is the ratio of the Balance of Payment (as % of commercial service imports) in Mauritius in 2008 to that in 2009?
Ensure brevity in your answer.  1.05. What is the ratio of the Balance of Payment (as % of commercial service imports) in Peru in 2008 to that in 2009?
Make the answer very short. 1.23. What is the ratio of the Balance of Payment (as % of commercial service imports) in Czech Republic in 2008 to that in 2010?
Offer a terse response. 0.93. What is the ratio of the Balance of Payment (as % of commercial service imports) of Mauritius in 2008 to that in 2010?
Provide a short and direct response. 1.19. What is the ratio of the Balance of Payment (as % of commercial service imports) of Peru in 2008 to that in 2010?
Give a very brief answer. 1.1. What is the ratio of the Balance of Payment (as % of commercial service imports) in Czech Republic in 2008 to that in 2011?
Keep it short and to the point. 0.97. What is the ratio of the Balance of Payment (as % of commercial service imports) in Mauritius in 2008 to that in 2011?
Offer a terse response. 1.34. What is the ratio of the Balance of Payment (as % of commercial service imports) of Peru in 2008 to that in 2011?
Ensure brevity in your answer.  1.16. What is the ratio of the Balance of Payment (as % of commercial service imports) of Czech Republic in 2008 to that in 2012?
Make the answer very short. 0.96. What is the ratio of the Balance of Payment (as % of commercial service imports) of Mauritius in 2008 to that in 2012?
Give a very brief answer. 1.35. What is the ratio of the Balance of Payment (as % of commercial service imports) in Peru in 2008 to that in 2012?
Your answer should be very brief. 1.16. What is the ratio of the Balance of Payment (as % of commercial service imports) in Czech Republic in 2008 to that in 2013?
Provide a succinct answer. 0.95. What is the ratio of the Balance of Payment (as % of commercial service imports) of Mauritius in 2008 to that in 2013?
Your answer should be compact. 1.51. What is the ratio of the Balance of Payment (as % of commercial service imports) in Peru in 2008 to that in 2013?
Give a very brief answer. 1.18. What is the ratio of the Balance of Payment (as % of commercial service imports) of Czech Republic in 2009 to that in 2010?
Offer a very short reply. 0.88. What is the ratio of the Balance of Payment (as % of commercial service imports) of Mauritius in 2009 to that in 2010?
Make the answer very short. 1.14. What is the ratio of the Balance of Payment (as % of commercial service imports) in Peru in 2009 to that in 2010?
Your answer should be compact. 0.89. What is the ratio of the Balance of Payment (as % of commercial service imports) of Czech Republic in 2009 to that in 2011?
Give a very brief answer. 0.91. What is the ratio of the Balance of Payment (as % of commercial service imports) in Mauritius in 2009 to that in 2011?
Your answer should be compact. 1.28. What is the ratio of the Balance of Payment (as % of commercial service imports) in Peru in 2009 to that in 2011?
Make the answer very short. 0.94. What is the ratio of the Balance of Payment (as % of commercial service imports) in Czech Republic in 2009 to that in 2012?
Make the answer very short. 0.9. What is the ratio of the Balance of Payment (as % of commercial service imports) in Mauritius in 2009 to that in 2012?
Offer a very short reply. 1.29. What is the ratio of the Balance of Payment (as % of commercial service imports) of Peru in 2009 to that in 2012?
Your response must be concise. 0.94. What is the ratio of the Balance of Payment (as % of commercial service imports) in Czech Republic in 2009 to that in 2013?
Your answer should be compact. 0.89. What is the ratio of the Balance of Payment (as % of commercial service imports) of Mauritius in 2009 to that in 2013?
Provide a succinct answer. 1.45. What is the ratio of the Balance of Payment (as % of commercial service imports) of Peru in 2009 to that in 2013?
Make the answer very short. 0.96. What is the ratio of the Balance of Payment (as % of commercial service imports) of Czech Republic in 2010 to that in 2011?
Provide a succinct answer. 1.03. What is the ratio of the Balance of Payment (as % of commercial service imports) in Mauritius in 2010 to that in 2011?
Ensure brevity in your answer.  1.12. What is the ratio of the Balance of Payment (as % of commercial service imports) in Peru in 2010 to that in 2011?
Your answer should be very brief. 1.05. What is the ratio of the Balance of Payment (as % of commercial service imports) of Czech Republic in 2010 to that in 2012?
Provide a succinct answer. 1.03. What is the ratio of the Balance of Payment (as % of commercial service imports) in Mauritius in 2010 to that in 2012?
Your answer should be very brief. 1.13. What is the ratio of the Balance of Payment (as % of commercial service imports) of Peru in 2010 to that in 2012?
Offer a very short reply. 1.05. What is the ratio of the Balance of Payment (as % of commercial service imports) in Czech Republic in 2010 to that in 2013?
Your response must be concise. 1.02. What is the ratio of the Balance of Payment (as % of commercial service imports) in Mauritius in 2010 to that in 2013?
Your answer should be compact. 1.27. What is the ratio of the Balance of Payment (as % of commercial service imports) in Peru in 2010 to that in 2013?
Your answer should be compact. 1.07. What is the ratio of the Balance of Payment (as % of commercial service imports) in Czech Republic in 2011 to that in 2012?
Provide a succinct answer. 1. What is the ratio of the Balance of Payment (as % of commercial service imports) in Czech Republic in 2011 to that in 2013?
Provide a short and direct response. 0.98. What is the ratio of the Balance of Payment (as % of commercial service imports) in Mauritius in 2011 to that in 2013?
Give a very brief answer. 1.13. What is the ratio of the Balance of Payment (as % of commercial service imports) in Czech Republic in 2012 to that in 2013?
Keep it short and to the point. 0.99. What is the ratio of the Balance of Payment (as % of commercial service imports) of Mauritius in 2012 to that in 2013?
Provide a succinct answer. 1.12. What is the ratio of the Balance of Payment (as % of commercial service imports) in Peru in 2012 to that in 2013?
Give a very brief answer. 1.02. What is the difference between the highest and the second highest Balance of Payment (as % of commercial service imports) in Czech Republic?
Provide a succinct answer. 0.1. What is the difference between the highest and the second highest Balance of Payment (as % of commercial service imports) in Mauritius?
Offer a terse response. 2.56. What is the difference between the highest and the second highest Balance of Payment (as % of commercial service imports) of Peru?
Offer a very short reply. 2.25. What is the difference between the highest and the lowest Balance of Payment (as % of commercial service imports) of Czech Republic?
Make the answer very short. 3.05. What is the difference between the highest and the lowest Balance of Payment (as % of commercial service imports) in Mauritius?
Your answer should be compact. 18.68. What is the difference between the highest and the lowest Balance of Payment (as % of commercial service imports) of Peru?
Provide a short and direct response. 8.71. 